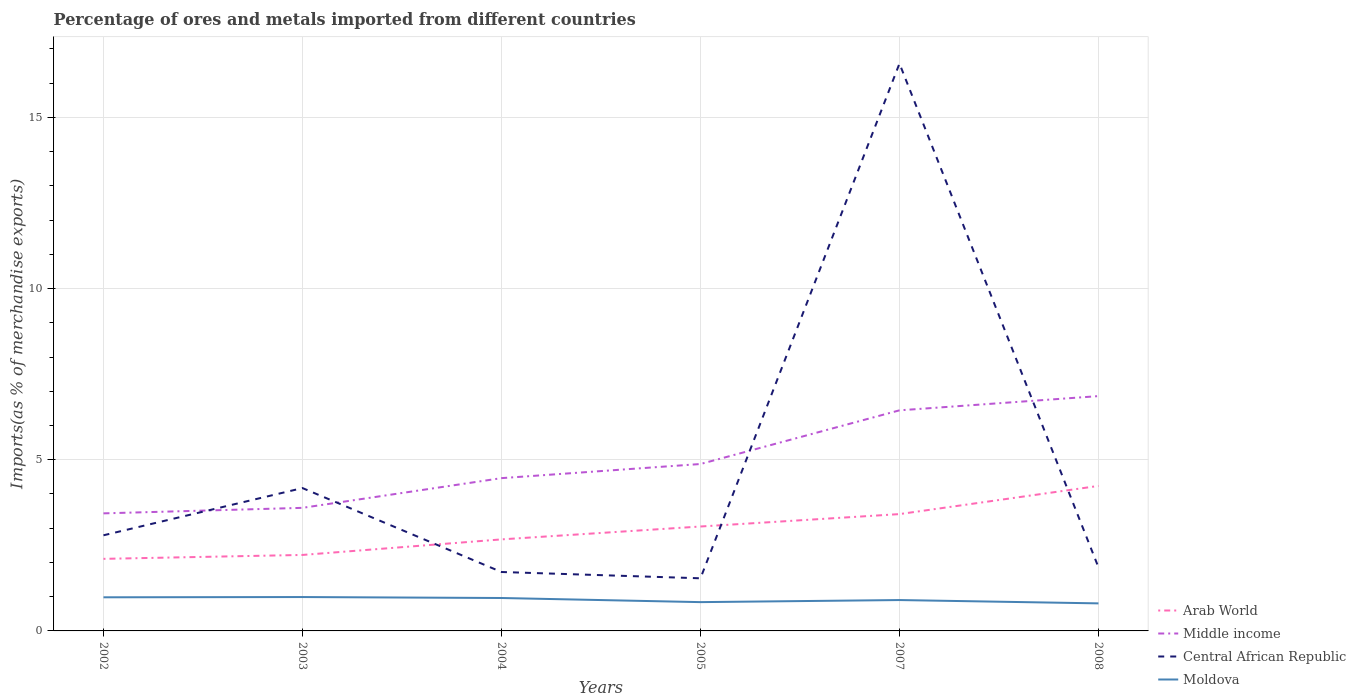Does the line corresponding to Arab World intersect with the line corresponding to Central African Republic?
Your response must be concise. Yes. Across all years, what is the maximum percentage of imports to different countries in Middle income?
Give a very brief answer. 3.43. In which year was the percentage of imports to different countries in Central African Republic maximum?
Offer a terse response. 2005. What is the total percentage of imports to different countries in Moldova in the graph?
Make the answer very short. 0.08. What is the difference between the highest and the second highest percentage of imports to different countries in Arab World?
Keep it short and to the point. 2.13. What is the difference between the highest and the lowest percentage of imports to different countries in Moldova?
Keep it short and to the point. 3. Is the percentage of imports to different countries in Arab World strictly greater than the percentage of imports to different countries in Moldova over the years?
Keep it short and to the point. No. How many years are there in the graph?
Your response must be concise. 6. Are the values on the major ticks of Y-axis written in scientific E-notation?
Your answer should be compact. No. Does the graph contain grids?
Offer a terse response. Yes. Where does the legend appear in the graph?
Your answer should be very brief. Bottom right. How many legend labels are there?
Offer a very short reply. 4. What is the title of the graph?
Provide a succinct answer. Percentage of ores and metals imported from different countries. Does "Belize" appear as one of the legend labels in the graph?
Offer a terse response. No. What is the label or title of the Y-axis?
Ensure brevity in your answer.  Imports(as % of merchandise exports). What is the Imports(as % of merchandise exports) in Arab World in 2002?
Offer a terse response. 2.11. What is the Imports(as % of merchandise exports) in Middle income in 2002?
Offer a terse response. 3.43. What is the Imports(as % of merchandise exports) in Central African Republic in 2002?
Give a very brief answer. 2.79. What is the Imports(as % of merchandise exports) in Moldova in 2002?
Make the answer very short. 0.98. What is the Imports(as % of merchandise exports) of Arab World in 2003?
Your answer should be compact. 2.22. What is the Imports(as % of merchandise exports) in Middle income in 2003?
Your answer should be very brief. 3.6. What is the Imports(as % of merchandise exports) of Central African Republic in 2003?
Ensure brevity in your answer.  4.17. What is the Imports(as % of merchandise exports) of Moldova in 2003?
Your answer should be compact. 0.99. What is the Imports(as % of merchandise exports) of Arab World in 2004?
Offer a terse response. 2.67. What is the Imports(as % of merchandise exports) of Middle income in 2004?
Provide a succinct answer. 4.46. What is the Imports(as % of merchandise exports) in Central African Republic in 2004?
Offer a very short reply. 1.72. What is the Imports(as % of merchandise exports) of Moldova in 2004?
Offer a very short reply. 0.96. What is the Imports(as % of merchandise exports) in Arab World in 2005?
Give a very brief answer. 3.05. What is the Imports(as % of merchandise exports) in Middle income in 2005?
Keep it short and to the point. 4.88. What is the Imports(as % of merchandise exports) of Central African Republic in 2005?
Your response must be concise. 1.54. What is the Imports(as % of merchandise exports) of Moldova in 2005?
Ensure brevity in your answer.  0.84. What is the Imports(as % of merchandise exports) in Arab World in 2007?
Your answer should be very brief. 3.41. What is the Imports(as % of merchandise exports) of Middle income in 2007?
Give a very brief answer. 6.44. What is the Imports(as % of merchandise exports) in Central African Republic in 2007?
Offer a very short reply. 16.57. What is the Imports(as % of merchandise exports) of Moldova in 2007?
Ensure brevity in your answer.  0.9. What is the Imports(as % of merchandise exports) of Arab World in 2008?
Your answer should be compact. 4.24. What is the Imports(as % of merchandise exports) in Middle income in 2008?
Give a very brief answer. 6.86. What is the Imports(as % of merchandise exports) in Central African Republic in 2008?
Keep it short and to the point. 1.86. What is the Imports(as % of merchandise exports) of Moldova in 2008?
Your response must be concise. 0.8. Across all years, what is the maximum Imports(as % of merchandise exports) in Arab World?
Provide a short and direct response. 4.24. Across all years, what is the maximum Imports(as % of merchandise exports) of Middle income?
Keep it short and to the point. 6.86. Across all years, what is the maximum Imports(as % of merchandise exports) in Central African Republic?
Offer a very short reply. 16.57. Across all years, what is the maximum Imports(as % of merchandise exports) of Moldova?
Offer a very short reply. 0.99. Across all years, what is the minimum Imports(as % of merchandise exports) in Arab World?
Your response must be concise. 2.11. Across all years, what is the minimum Imports(as % of merchandise exports) in Middle income?
Offer a very short reply. 3.43. Across all years, what is the minimum Imports(as % of merchandise exports) of Central African Republic?
Your answer should be compact. 1.54. Across all years, what is the minimum Imports(as % of merchandise exports) in Moldova?
Ensure brevity in your answer.  0.8. What is the total Imports(as % of merchandise exports) in Arab World in the graph?
Your answer should be compact. 17.7. What is the total Imports(as % of merchandise exports) of Middle income in the graph?
Your answer should be very brief. 29.67. What is the total Imports(as % of merchandise exports) of Central African Republic in the graph?
Ensure brevity in your answer.  28.66. What is the total Imports(as % of merchandise exports) of Moldova in the graph?
Make the answer very short. 5.48. What is the difference between the Imports(as % of merchandise exports) in Arab World in 2002 and that in 2003?
Offer a terse response. -0.11. What is the difference between the Imports(as % of merchandise exports) of Middle income in 2002 and that in 2003?
Make the answer very short. -0.16. What is the difference between the Imports(as % of merchandise exports) in Central African Republic in 2002 and that in 2003?
Provide a short and direct response. -1.38. What is the difference between the Imports(as % of merchandise exports) of Moldova in 2002 and that in 2003?
Your response must be concise. -0.01. What is the difference between the Imports(as % of merchandise exports) of Arab World in 2002 and that in 2004?
Offer a very short reply. -0.57. What is the difference between the Imports(as % of merchandise exports) of Middle income in 2002 and that in 2004?
Provide a short and direct response. -1.03. What is the difference between the Imports(as % of merchandise exports) in Central African Republic in 2002 and that in 2004?
Your answer should be very brief. 1.07. What is the difference between the Imports(as % of merchandise exports) in Moldova in 2002 and that in 2004?
Offer a very short reply. 0.02. What is the difference between the Imports(as % of merchandise exports) of Arab World in 2002 and that in 2005?
Ensure brevity in your answer.  -0.94. What is the difference between the Imports(as % of merchandise exports) in Middle income in 2002 and that in 2005?
Offer a terse response. -1.44. What is the difference between the Imports(as % of merchandise exports) of Central African Republic in 2002 and that in 2005?
Your answer should be very brief. 1.26. What is the difference between the Imports(as % of merchandise exports) in Moldova in 2002 and that in 2005?
Provide a succinct answer. 0.14. What is the difference between the Imports(as % of merchandise exports) of Arab World in 2002 and that in 2007?
Provide a short and direct response. -1.31. What is the difference between the Imports(as % of merchandise exports) of Middle income in 2002 and that in 2007?
Provide a succinct answer. -3.01. What is the difference between the Imports(as % of merchandise exports) in Central African Republic in 2002 and that in 2007?
Give a very brief answer. -13.78. What is the difference between the Imports(as % of merchandise exports) in Moldova in 2002 and that in 2007?
Your answer should be very brief. 0.08. What is the difference between the Imports(as % of merchandise exports) in Arab World in 2002 and that in 2008?
Offer a terse response. -2.13. What is the difference between the Imports(as % of merchandise exports) of Middle income in 2002 and that in 2008?
Give a very brief answer. -3.43. What is the difference between the Imports(as % of merchandise exports) of Central African Republic in 2002 and that in 2008?
Your answer should be very brief. 0.94. What is the difference between the Imports(as % of merchandise exports) in Moldova in 2002 and that in 2008?
Your response must be concise. 0.18. What is the difference between the Imports(as % of merchandise exports) in Arab World in 2003 and that in 2004?
Your answer should be compact. -0.45. What is the difference between the Imports(as % of merchandise exports) of Middle income in 2003 and that in 2004?
Give a very brief answer. -0.87. What is the difference between the Imports(as % of merchandise exports) of Central African Republic in 2003 and that in 2004?
Ensure brevity in your answer.  2.45. What is the difference between the Imports(as % of merchandise exports) in Moldova in 2003 and that in 2004?
Give a very brief answer. 0.03. What is the difference between the Imports(as % of merchandise exports) in Arab World in 2003 and that in 2005?
Offer a very short reply. -0.83. What is the difference between the Imports(as % of merchandise exports) of Middle income in 2003 and that in 2005?
Provide a succinct answer. -1.28. What is the difference between the Imports(as % of merchandise exports) in Central African Republic in 2003 and that in 2005?
Your answer should be very brief. 2.64. What is the difference between the Imports(as % of merchandise exports) of Moldova in 2003 and that in 2005?
Make the answer very short. 0.15. What is the difference between the Imports(as % of merchandise exports) of Arab World in 2003 and that in 2007?
Offer a very short reply. -1.19. What is the difference between the Imports(as % of merchandise exports) in Middle income in 2003 and that in 2007?
Your answer should be very brief. -2.85. What is the difference between the Imports(as % of merchandise exports) in Central African Republic in 2003 and that in 2007?
Your response must be concise. -12.4. What is the difference between the Imports(as % of merchandise exports) of Moldova in 2003 and that in 2007?
Ensure brevity in your answer.  0.09. What is the difference between the Imports(as % of merchandise exports) in Arab World in 2003 and that in 2008?
Your answer should be compact. -2.02. What is the difference between the Imports(as % of merchandise exports) in Middle income in 2003 and that in 2008?
Keep it short and to the point. -3.26. What is the difference between the Imports(as % of merchandise exports) of Central African Republic in 2003 and that in 2008?
Give a very brief answer. 2.32. What is the difference between the Imports(as % of merchandise exports) in Moldova in 2003 and that in 2008?
Keep it short and to the point. 0.18. What is the difference between the Imports(as % of merchandise exports) of Arab World in 2004 and that in 2005?
Make the answer very short. -0.38. What is the difference between the Imports(as % of merchandise exports) in Middle income in 2004 and that in 2005?
Make the answer very short. -0.41. What is the difference between the Imports(as % of merchandise exports) of Central African Republic in 2004 and that in 2005?
Provide a succinct answer. 0.18. What is the difference between the Imports(as % of merchandise exports) of Moldova in 2004 and that in 2005?
Your answer should be very brief. 0.12. What is the difference between the Imports(as % of merchandise exports) of Arab World in 2004 and that in 2007?
Your answer should be compact. -0.74. What is the difference between the Imports(as % of merchandise exports) in Middle income in 2004 and that in 2007?
Your answer should be very brief. -1.98. What is the difference between the Imports(as % of merchandise exports) of Central African Republic in 2004 and that in 2007?
Ensure brevity in your answer.  -14.85. What is the difference between the Imports(as % of merchandise exports) in Moldova in 2004 and that in 2007?
Provide a short and direct response. 0.06. What is the difference between the Imports(as % of merchandise exports) in Arab World in 2004 and that in 2008?
Provide a succinct answer. -1.56. What is the difference between the Imports(as % of merchandise exports) in Middle income in 2004 and that in 2008?
Offer a terse response. -2.4. What is the difference between the Imports(as % of merchandise exports) in Central African Republic in 2004 and that in 2008?
Ensure brevity in your answer.  -0.14. What is the difference between the Imports(as % of merchandise exports) in Moldova in 2004 and that in 2008?
Make the answer very short. 0.16. What is the difference between the Imports(as % of merchandise exports) of Arab World in 2005 and that in 2007?
Your response must be concise. -0.36. What is the difference between the Imports(as % of merchandise exports) in Middle income in 2005 and that in 2007?
Give a very brief answer. -1.57. What is the difference between the Imports(as % of merchandise exports) of Central African Republic in 2005 and that in 2007?
Your response must be concise. -15.04. What is the difference between the Imports(as % of merchandise exports) in Moldova in 2005 and that in 2007?
Provide a short and direct response. -0.06. What is the difference between the Imports(as % of merchandise exports) of Arab World in 2005 and that in 2008?
Keep it short and to the point. -1.19. What is the difference between the Imports(as % of merchandise exports) of Middle income in 2005 and that in 2008?
Your response must be concise. -1.98. What is the difference between the Imports(as % of merchandise exports) of Central African Republic in 2005 and that in 2008?
Give a very brief answer. -0.32. What is the difference between the Imports(as % of merchandise exports) in Moldova in 2005 and that in 2008?
Make the answer very short. 0.04. What is the difference between the Imports(as % of merchandise exports) in Arab World in 2007 and that in 2008?
Your answer should be compact. -0.82. What is the difference between the Imports(as % of merchandise exports) of Middle income in 2007 and that in 2008?
Offer a very short reply. -0.42. What is the difference between the Imports(as % of merchandise exports) of Central African Republic in 2007 and that in 2008?
Offer a terse response. 14.72. What is the difference between the Imports(as % of merchandise exports) of Moldova in 2007 and that in 2008?
Give a very brief answer. 0.1. What is the difference between the Imports(as % of merchandise exports) of Arab World in 2002 and the Imports(as % of merchandise exports) of Middle income in 2003?
Provide a short and direct response. -1.49. What is the difference between the Imports(as % of merchandise exports) of Arab World in 2002 and the Imports(as % of merchandise exports) of Central African Republic in 2003?
Ensure brevity in your answer.  -2.07. What is the difference between the Imports(as % of merchandise exports) of Arab World in 2002 and the Imports(as % of merchandise exports) of Moldova in 2003?
Your response must be concise. 1.12. What is the difference between the Imports(as % of merchandise exports) in Middle income in 2002 and the Imports(as % of merchandise exports) in Central African Republic in 2003?
Your answer should be compact. -0.74. What is the difference between the Imports(as % of merchandise exports) of Middle income in 2002 and the Imports(as % of merchandise exports) of Moldova in 2003?
Keep it short and to the point. 2.44. What is the difference between the Imports(as % of merchandise exports) of Central African Republic in 2002 and the Imports(as % of merchandise exports) of Moldova in 2003?
Ensure brevity in your answer.  1.8. What is the difference between the Imports(as % of merchandise exports) in Arab World in 2002 and the Imports(as % of merchandise exports) in Middle income in 2004?
Provide a short and direct response. -2.36. What is the difference between the Imports(as % of merchandise exports) of Arab World in 2002 and the Imports(as % of merchandise exports) of Central African Republic in 2004?
Make the answer very short. 0.38. What is the difference between the Imports(as % of merchandise exports) of Arab World in 2002 and the Imports(as % of merchandise exports) of Moldova in 2004?
Make the answer very short. 1.14. What is the difference between the Imports(as % of merchandise exports) of Middle income in 2002 and the Imports(as % of merchandise exports) of Central African Republic in 2004?
Keep it short and to the point. 1.71. What is the difference between the Imports(as % of merchandise exports) of Middle income in 2002 and the Imports(as % of merchandise exports) of Moldova in 2004?
Make the answer very short. 2.47. What is the difference between the Imports(as % of merchandise exports) in Central African Republic in 2002 and the Imports(as % of merchandise exports) in Moldova in 2004?
Provide a short and direct response. 1.83. What is the difference between the Imports(as % of merchandise exports) of Arab World in 2002 and the Imports(as % of merchandise exports) of Middle income in 2005?
Provide a succinct answer. -2.77. What is the difference between the Imports(as % of merchandise exports) in Arab World in 2002 and the Imports(as % of merchandise exports) in Central African Republic in 2005?
Ensure brevity in your answer.  0.57. What is the difference between the Imports(as % of merchandise exports) in Arab World in 2002 and the Imports(as % of merchandise exports) in Moldova in 2005?
Give a very brief answer. 1.26. What is the difference between the Imports(as % of merchandise exports) in Middle income in 2002 and the Imports(as % of merchandise exports) in Central African Republic in 2005?
Your answer should be compact. 1.9. What is the difference between the Imports(as % of merchandise exports) in Middle income in 2002 and the Imports(as % of merchandise exports) in Moldova in 2005?
Your answer should be very brief. 2.59. What is the difference between the Imports(as % of merchandise exports) in Central African Republic in 2002 and the Imports(as % of merchandise exports) in Moldova in 2005?
Ensure brevity in your answer.  1.95. What is the difference between the Imports(as % of merchandise exports) in Arab World in 2002 and the Imports(as % of merchandise exports) in Middle income in 2007?
Your answer should be very brief. -4.34. What is the difference between the Imports(as % of merchandise exports) in Arab World in 2002 and the Imports(as % of merchandise exports) in Central African Republic in 2007?
Offer a terse response. -14.47. What is the difference between the Imports(as % of merchandise exports) of Arab World in 2002 and the Imports(as % of merchandise exports) of Moldova in 2007?
Make the answer very short. 1.2. What is the difference between the Imports(as % of merchandise exports) of Middle income in 2002 and the Imports(as % of merchandise exports) of Central African Republic in 2007?
Offer a terse response. -13.14. What is the difference between the Imports(as % of merchandise exports) in Middle income in 2002 and the Imports(as % of merchandise exports) in Moldova in 2007?
Offer a very short reply. 2.53. What is the difference between the Imports(as % of merchandise exports) in Central African Republic in 2002 and the Imports(as % of merchandise exports) in Moldova in 2007?
Give a very brief answer. 1.89. What is the difference between the Imports(as % of merchandise exports) in Arab World in 2002 and the Imports(as % of merchandise exports) in Middle income in 2008?
Make the answer very short. -4.75. What is the difference between the Imports(as % of merchandise exports) in Arab World in 2002 and the Imports(as % of merchandise exports) in Central African Republic in 2008?
Provide a succinct answer. 0.25. What is the difference between the Imports(as % of merchandise exports) of Arab World in 2002 and the Imports(as % of merchandise exports) of Moldova in 2008?
Give a very brief answer. 1.3. What is the difference between the Imports(as % of merchandise exports) of Middle income in 2002 and the Imports(as % of merchandise exports) of Central African Republic in 2008?
Provide a succinct answer. 1.58. What is the difference between the Imports(as % of merchandise exports) in Middle income in 2002 and the Imports(as % of merchandise exports) in Moldova in 2008?
Your answer should be compact. 2.63. What is the difference between the Imports(as % of merchandise exports) in Central African Republic in 2002 and the Imports(as % of merchandise exports) in Moldova in 2008?
Keep it short and to the point. 1.99. What is the difference between the Imports(as % of merchandise exports) of Arab World in 2003 and the Imports(as % of merchandise exports) of Middle income in 2004?
Give a very brief answer. -2.24. What is the difference between the Imports(as % of merchandise exports) of Arab World in 2003 and the Imports(as % of merchandise exports) of Central African Republic in 2004?
Offer a very short reply. 0.5. What is the difference between the Imports(as % of merchandise exports) in Arab World in 2003 and the Imports(as % of merchandise exports) in Moldova in 2004?
Offer a terse response. 1.26. What is the difference between the Imports(as % of merchandise exports) of Middle income in 2003 and the Imports(as % of merchandise exports) of Central African Republic in 2004?
Offer a very short reply. 1.87. What is the difference between the Imports(as % of merchandise exports) of Middle income in 2003 and the Imports(as % of merchandise exports) of Moldova in 2004?
Provide a succinct answer. 2.63. What is the difference between the Imports(as % of merchandise exports) in Central African Republic in 2003 and the Imports(as % of merchandise exports) in Moldova in 2004?
Your answer should be very brief. 3.21. What is the difference between the Imports(as % of merchandise exports) in Arab World in 2003 and the Imports(as % of merchandise exports) in Middle income in 2005?
Offer a terse response. -2.66. What is the difference between the Imports(as % of merchandise exports) in Arab World in 2003 and the Imports(as % of merchandise exports) in Central African Republic in 2005?
Your answer should be very brief. 0.68. What is the difference between the Imports(as % of merchandise exports) of Arab World in 2003 and the Imports(as % of merchandise exports) of Moldova in 2005?
Give a very brief answer. 1.38. What is the difference between the Imports(as % of merchandise exports) in Middle income in 2003 and the Imports(as % of merchandise exports) in Central African Republic in 2005?
Keep it short and to the point. 2.06. What is the difference between the Imports(as % of merchandise exports) of Middle income in 2003 and the Imports(as % of merchandise exports) of Moldova in 2005?
Ensure brevity in your answer.  2.75. What is the difference between the Imports(as % of merchandise exports) in Central African Republic in 2003 and the Imports(as % of merchandise exports) in Moldova in 2005?
Offer a very short reply. 3.33. What is the difference between the Imports(as % of merchandise exports) of Arab World in 2003 and the Imports(as % of merchandise exports) of Middle income in 2007?
Make the answer very short. -4.22. What is the difference between the Imports(as % of merchandise exports) in Arab World in 2003 and the Imports(as % of merchandise exports) in Central African Republic in 2007?
Give a very brief answer. -14.35. What is the difference between the Imports(as % of merchandise exports) of Arab World in 2003 and the Imports(as % of merchandise exports) of Moldova in 2007?
Your answer should be very brief. 1.32. What is the difference between the Imports(as % of merchandise exports) of Middle income in 2003 and the Imports(as % of merchandise exports) of Central African Republic in 2007?
Provide a succinct answer. -12.98. What is the difference between the Imports(as % of merchandise exports) in Middle income in 2003 and the Imports(as % of merchandise exports) in Moldova in 2007?
Your response must be concise. 2.69. What is the difference between the Imports(as % of merchandise exports) in Central African Republic in 2003 and the Imports(as % of merchandise exports) in Moldova in 2007?
Offer a terse response. 3.27. What is the difference between the Imports(as % of merchandise exports) of Arab World in 2003 and the Imports(as % of merchandise exports) of Middle income in 2008?
Ensure brevity in your answer.  -4.64. What is the difference between the Imports(as % of merchandise exports) of Arab World in 2003 and the Imports(as % of merchandise exports) of Central African Republic in 2008?
Provide a short and direct response. 0.36. What is the difference between the Imports(as % of merchandise exports) in Arab World in 2003 and the Imports(as % of merchandise exports) in Moldova in 2008?
Provide a short and direct response. 1.41. What is the difference between the Imports(as % of merchandise exports) of Middle income in 2003 and the Imports(as % of merchandise exports) of Central African Republic in 2008?
Provide a succinct answer. 1.74. What is the difference between the Imports(as % of merchandise exports) of Middle income in 2003 and the Imports(as % of merchandise exports) of Moldova in 2008?
Your answer should be compact. 2.79. What is the difference between the Imports(as % of merchandise exports) in Central African Republic in 2003 and the Imports(as % of merchandise exports) in Moldova in 2008?
Your response must be concise. 3.37. What is the difference between the Imports(as % of merchandise exports) in Arab World in 2004 and the Imports(as % of merchandise exports) in Middle income in 2005?
Provide a succinct answer. -2.2. What is the difference between the Imports(as % of merchandise exports) in Arab World in 2004 and the Imports(as % of merchandise exports) in Central African Republic in 2005?
Your response must be concise. 1.14. What is the difference between the Imports(as % of merchandise exports) of Arab World in 2004 and the Imports(as % of merchandise exports) of Moldova in 2005?
Offer a very short reply. 1.83. What is the difference between the Imports(as % of merchandise exports) of Middle income in 2004 and the Imports(as % of merchandise exports) of Central African Republic in 2005?
Make the answer very short. 2.93. What is the difference between the Imports(as % of merchandise exports) of Middle income in 2004 and the Imports(as % of merchandise exports) of Moldova in 2005?
Give a very brief answer. 3.62. What is the difference between the Imports(as % of merchandise exports) in Central African Republic in 2004 and the Imports(as % of merchandise exports) in Moldova in 2005?
Provide a short and direct response. 0.88. What is the difference between the Imports(as % of merchandise exports) of Arab World in 2004 and the Imports(as % of merchandise exports) of Middle income in 2007?
Offer a terse response. -3.77. What is the difference between the Imports(as % of merchandise exports) of Arab World in 2004 and the Imports(as % of merchandise exports) of Central African Republic in 2007?
Ensure brevity in your answer.  -13.9. What is the difference between the Imports(as % of merchandise exports) in Arab World in 2004 and the Imports(as % of merchandise exports) in Moldova in 2007?
Your answer should be compact. 1.77. What is the difference between the Imports(as % of merchandise exports) in Middle income in 2004 and the Imports(as % of merchandise exports) in Central African Republic in 2007?
Your answer should be very brief. -12.11. What is the difference between the Imports(as % of merchandise exports) in Middle income in 2004 and the Imports(as % of merchandise exports) in Moldova in 2007?
Your answer should be very brief. 3.56. What is the difference between the Imports(as % of merchandise exports) of Central African Republic in 2004 and the Imports(as % of merchandise exports) of Moldova in 2007?
Your response must be concise. 0.82. What is the difference between the Imports(as % of merchandise exports) in Arab World in 2004 and the Imports(as % of merchandise exports) in Middle income in 2008?
Offer a terse response. -4.19. What is the difference between the Imports(as % of merchandise exports) in Arab World in 2004 and the Imports(as % of merchandise exports) in Central African Republic in 2008?
Ensure brevity in your answer.  0.82. What is the difference between the Imports(as % of merchandise exports) of Arab World in 2004 and the Imports(as % of merchandise exports) of Moldova in 2008?
Keep it short and to the point. 1.87. What is the difference between the Imports(as % of merchandise exports) in Middle income in 2004 and the Imports(as % of merchandise exports) in Central African Republic in 2008?
Your answer should be compact. 2.61. What is the difference between the Imports(as % of merchandise exports) of Middle income in 2004 and the Imports(as % of merchandise exports) of Moldova in 2008?
Your response must be concise. 3.66. What is the difference between the Imports(as % of merchandise exports) of Central African Republic in 2004 and the Imports(as % of merchandise exports) of Moldova in 2008?
Provide a succinct answer. 0.92. What is the difference between the Imports(as % of merchandise exports) of Arab World in 2005 and the Imports(as % of merchandise exports) of Middle income in 2007?
Your response must be concise. -3.39. What is the difference between the Imports(as % of merchandise exports) of Arab World in 2005 and the Imports(as % of merchandise exports) of Central African Republic in 2007?
Ensure brevity in your answer.  -13.52. What is the difference between the Imports(as % of merchandise exports) of Arab World in 2005 and the Imports(as % of merchandise exports) of Moldova in 2007?
Give a very brief answer. 2.15. What is the difference between the Imports(as % of merchandise exports) in Middle income in 2005 and the Imports(as % of merchandise exports) in Central African Republic in 2007?
Your response must be concise. -11.7. What is the difference between the Imports(as % of merchandise exports) of Middle income in 2005 and the Imports(as % of merchandise exports) of Moldova in 2007?
Give a very brief answer. 3.97. What is the difference between the Imports(as % of merchandise exports) in Central African Republic in 2005 and the Imports(as % of merchandise exports) in Moldova in 2007?
Ensure brevity in your answer.  0.64. What is the difference between the Imports(as % of merchandise exports) of Arab World in 2005 and the Imports(as % of merchandise exports) of Middle income in 2008?
Your answer should be compact. -3.81. What is the difference between the Imports(as % of merchandise exports) in Arab World in 2005 and the Imports(as % of merchandise exports) in Central African Republic in 2008?
Your response must be concise. 1.19. What is the difference between the Imports(as % of merchandise exports) in Arab World in 2005 and the Imports(as % of merchandise exports) in Moldova in 2008?
Your response must be concise. 2.25. What is the difference between the Imports(as % of merchandise exports) of Middle income in 2005 and the Imports(as % of merchandise exports) of Central African Republic in 2008?
Provide a short and direct response. 3.02. What is the difference between the Imports(as % of merchandise exports) of Middle income in 2005 and the Imports(as % of merchandise exports) of Moldova in 2008?
Offer a terse response. 4.07. What is the difference between the Imports(as % of merchandise exports) in Central African Republic in 2005 and the Imports(as % of merchandise exports) in Moldova in 2008?
Offer a very short reply. 0.73. What is the difference between the Imports(as % of merchandise exports) of Arab World in 2007 and the Imports(as % of merchandise exports) of Middle income in 2008?
Give a very brief answer. -3.45. What is the difference between the Imports(as % of merchandise exports) of Arab World in 2007 and the Imports(as % of merchandise exports) of Central African Republic in 2008?
Offer a very short reply. 1.56. What is the difference between the Imports(as % of merchandise exports) in Arab World in 2007 and the Imports(as % of merchandise exports) in Moldova in 2008?
Offer a terse response. 2.61. What is the difference between the Imports(as % of merchandise exports) of Middle income in 2007 and the Imports(as % of merchandise exports) of Central African Republic in 2008?
Offer a very short reply. 4.59. What is the difference between the Imports(as % of merchandise exports) in Middle income in 2007 and the Imports(as % of merchandise exports) in Moldova in 2008?
Make the answer very short. 5.64. What is the difference between the Imports(as % of merchandise exports) of Central African Republic in 2007 and the Imports(as % of merchandise exports) of Moldova in 2008?
Your answer should be compact. 15.77. What is the average Imports(as % of merchandise exports) of Arab World per year?
Give a very brief answer. 2.95. What is the average Imports(as % of merchandise exports) of Middle income per year?
Offer a terse response. 4.95. What is the average Imports(as % of merchandise exports) in Central African Republic per year?
Provide a short and direct response. 4.78. What is the average Imports(as % of merchandise exports) in Moldova per year?
Offer a very short reply. 0.91. In the year 2002, what is the difference between the Imports(as % of merchandise exports) of Arab World and Imports(as % of merchandise exports) of Middle income?
Offer a very short reply. -1.33. In the year 2002, what is the difference between the Imports(as % of merchandise exports) in Arab World and Imports(as % of merchandise exports) in Central African Republic?
Offer a very short reply. -0.69. In the year 2002, what is the difference between the Imports(as % of merchandise exports) of Arab World and Imports(as % of merchandise exports) of Moldova?
Ensure brevity in your answer.  1.12. In the year 2002, what is the difference between the Imports(as % of merchandise exports) in Middle income and Imports(as % of merchandise exports) in Central African Republic?
Offer a terse response. 0.64. In the year 2002, what is the difference between the Imports(as % of merchandise exports) in Middle income and Imports(as % of merchandise exports) in Moldova?
Give a very brief answer. 2.45. In the year 2002, what is the difference between the Imports(as % of merchandise exports) of Central African Republic and Imports(as % of merchandise exports) of Moldova?
Offer a terse response. 1.81. In the year 2003, what is the difference between the Imports(as % of merchandise exports) of Arab World and Imports(as % of merchandise exports) of Middle income?
Your answer should be compact. -1.38. In the year 2003, what is the difference between the Imports(as % of merchandise exports) of Arab World and Imports(as % of merchandise exports) of Central African Republic?
Your answer should be very brief. -1.95. In the year 2003, what is the difference between the Imports(as % of merchandise exports) of Arab World and Imports(as % of merchandise exports) of Moldova?
Provide a short and direct response. 1.23. In the year 2003, what is the difference between the Imports(as % of merchandise exports) of Middle income and Imports(as % of merchandise exports) of Central African Republic?
Offer a terse response. -0.58. In the year 2003, what is the difference between the Imports(as % of merchandise exports) in Middle income and Imports(as % of merchandise exports) in Moldova?
Give a very brief answer. 2.61. In the year 2003, what is the difference between the Imports(as % of merchandise exports) of Central African Republic and Imports(as % of merchandise exports) of Moldova?
Make the answer very short. 3.18. In the year 2004, what is the difference between the Imports(as % of merchandise exports) in Arab World and Imports(as % of merchandise exports) in Middle income?
Make the answer very short. -1.79. In the year 2004, what is the difference between the Imports(as % of merchandise exports) in Arab World and Imports(as % of merchandise exports) in Central African Republic?
Give a very brief answer. 0.95. In the year 2004, what is the difference between the Imports(as % of merchandise exports) of Arab World and Imports(as % of merchandise exports) of Moldova?
Provide a succinct answer. 1.71. In the year 2004, what is the difference between the Imports(as % of merchandise exports) of Middle income and Imports(as % of merchandise exports) of Central African Republic?
Provide a short and direct response. 2.74. In the year 2004, what is the difference between the Imports(as % of merchandise exports) of Middle income and Imports(as % of merchandise exports) of Moldova?
Ensure brevity in your answer.  3.5. In the year 2004, what is the difference between the Imports(as % of merchandise exports) in Central African Republic and Imports(as % of merchandise exports) in Moldova?
Provide a succinct answer. 0.76. In the year 2005, what is the difference between the Imports(as % of merchandise exports) of Arab World and Imports(as % of merchandise exports) of Middle income?
Offer a terse response. -1.83. In the year 2005, what is the difference between the Imports(as % of merchandise exports) of Arab World and Imports(as % of merchandise exports) of Central African Republic?
Give a very brief answer. 1.51. In the year 2005, what is the difference between the Imports(as % of merchandise exports) of Arab World and Imports(as % of merchandise exports) of Moldova?
Keep it short and to the point. 2.21. In the year 2005, what is the difference between the Imports(as % of merchandise exports) of Middle income and Imports(as % of merchandise exports) of Central African Republic?
Your response must be concise. 3.34. In the year 2005, what is the difference between the Imports(as % of merchandise exports) of Middle income and Imports(as % of merchandise exports) of Moldova?
Ensure brevity in your answer.  4.03. In the year 2005, what is the difference between the Imports(as % of merchandise exports) of Central African Republic and Imports(as % of merchandise exports) of Moldova?
Ensure brevity in your answer.  0.7. In the year 2007, what is the difference between the Imports(as % of merchandise exports) of Arab World and Imports(as % of merchandise exports) of Middle income?
Ensure brevity in your answer.  -3.03. In the year 2007, what is the difference between the Imports(as % of merchandise exports) of Arab World and Imports(as % of merchandise exports) of Central African Republic?
Ensure brevity in your answer.  -13.16. In the year 2007, what is the difference between the Imports(as % of merchandise exports) of Arab World and Imports(as % of merchandise exports) of Moldova?
Keep it short and to the point. 2.51. In the year 2007, what is the difference between the Imports(as % of merchandise exports) of Middle income and Imports(as % of merchandise exports) of Central African Republic?
Offer a very short reply. -10.13. In the year 2007, what is the difference between the Imports(as % of merchandise exports) of Middle income and Imports(as % of merchandise exports) of Moldova?
Provide a short and direct response. 5.54. In the year 2007, what is the difference between the Imports(as % of merchandise exports) in Central African Republic and Imports(as % of merchandise exports) in Moldova?
Keep it short and to the point. 15.67. In the year 2008, what is the difference between the Imports(as % of merchandise exports) of Arab World and Imports(as % of merchandise exports) of Middle income?
Your response must be concise. -2.62. In the year 2008, what is the difference between the Imports(as % of merchandise exports) of Arab World and Imports(as % of merchandise exports) of Central African Republic?
Offer a terse response. 2.38. In the year 2008, what is the difference between the Imports(as % of merchandise exports) in Arab World and Imports(as % of merchandise exports) in Moldova?
Give a very brief answer. 3.43. In the year 2008, what is the difference between the Imports(as % of merchandise exports) of Middle income and Imports(as % of merchandise exports) of Central African Republic?
Give a very brief answer. 5. In the year 2008, what is the difference between the Imports(as % of merchandise exports) in Middle income and Imports(as % of merchandise exports) in Moldova?
Ensure brevity in your answer.  6.05. In the year 2008, what is the difference between the Imports(as % of merchandise exports) of Central African Republic and Imports(as % of merchandise exports) of Moldova?
Ensure brevity in your answer.  1.05. What is the ratio of the Imports(as % of merchandise exports) in Arab World in 2002 to that in 2003?
Provide a succinct answer. 0.95. What is the ratio of the Imports(as % of merchandise exports) of Middle income in 2002 to that in 2003?
Your response must be concise. 0.96. What is the ratio of the Imports(as % of merchandise exports) of Central African Republic in 2002 to that in 2003?
Your answer should be very brief. 0.67. What is the ratio of the Imports(as % of merchandise exports) in Moldova in 2002 to that in 2003?
Provide a succinct answer. 0.99. What is the ratio of the Imports(as % of merchandise exports) in Arab World in 2002 to that in 2004?
Ensure brevity in your answer.  0.79. What is the ratio of the Imports(as % of merchandise exports) in Middle income in 2002 to that in 2004?
Offer a terse response. 0.77. What is the ratio of the Imports(as % of merchandise exports) of Central African Republic in 2002 to that in 2004?
Offer a very short reply. 1.62. What is the ratio of the Imports(as % of merchandise exports) in Moldova in 2002 to that in 2004?
Give a very brief answer. 1.02. What is the ratio of the Imports(as % of merchandise exports) in Arab World in 2002 to that in 2005?
Provide a succinct answer. 0.69. What is the ratio of the Imports(as % of merchandise exports) in Middle income in 2002 to that in 2005?
Make the answer very short. 0.7. What is the ratio of the Imports(as % of merchandise exports) of Central African Republic in 2002 to that in 2005?
Your answer should be very brief. 1.82. What is the ratio of the Imports(as % of merchandise exports) in Moldova in 2002 to that in 2005?
Make the answer very short. 1.17. What is the ratio of the Imports(as % of merchandise exports) in Arab World in 2002 to that in 2007?
Offer a very short reply. 0.62. What is the ratio of the Imports(as % of merchandise exports) of Middle income in 2002 to that in 2007?
Give a very brief answer. 0.53. What is the ratio of the Imports(as % of merchandise exports) of Central African Republic in 2002 to that in 2007?
Your answer should be compact. 0.17. What is the ratio of the Imports(as % of merchandise exports) of Moldova in 2002 to that in 2007?
Offer a terse response. 1.09. What is the ratio of the Imports(as % of merchandise exports) of Arab World in 2002 to that in 2008?
Keep it short and to the point. 0.5. What is the ratio of the Imports(as % of merchandise exports) of Middle income in 2002 to that in 2008?
Your answer should be very brief. 0.5. What is the ratio of the Imports(as % of merchandise exports) in Central African Republic in 2002 to that in 2008?
Provide a succinct answer. 1.5. What is the ratio of the Imports(as % of merchandise exports) of Moldova in 2002 to that in 2008?
Offer a very short reply. 1.22. What is the ratio of the Imports(as % of merchandise exports) of Arab World in 2003 to that in 2004?
Keep it short and to the point. 0.83. What is the ratio of the Imports(as % of merchandise exports) of Middle income in 2003 to that in 2004?
Your answer should be compact. 0.81. What is the ratio of the Imports(as % of merchandise exports) of Central African Republic in 2003 to that in 2004?
Make the answer very short. 2.42. What is the ratio of the Imports(as % of merchandise exports) in Moldova in 2003 to that in 2004?
Give a very brief answer. 1.03. What is the ratio of the Imports(as % of merchandise exports) of Arab World in 2003 to that in 2005?
Provide a short and direct response. 0.73. What is the ratio of the Imports(as % of merchandise exports) of Middle income in 2003 to that in 2005?
Ensure brevity in your answer.  0.74. What is the ratio of the Imports(as % of merchandise exports) in Central African Republic in 2003 to that in 2005?
Offer a terse response. 2.71. What is the ratio of the Imports(as % of merchandise exports) in Moldova in 2003 to that in 2005?
Ensure brevity in your answer.  1.18. What is the ratio of the Imports(as % of merchandise exports) of Arab World in 2003 to that in 2007?
Give a very brief answer. 0.65. What is the ratio of the Imports(as % of merchandise exports) in Middle income in 2003 to that in 2007?
Make the answer very short. 0.56. What is the ratio of the Imports(as % of merchandise exports) in Central African Republic in 2003 to that in 2007?
Offer a very short reply. 0.25. What is the ratio of the Imports(as % of merchandise exports) of Moldova in 2003 to that in 2007?
Make the answer very short. 1.1. What is the ratio of the Imports(as % of merchandise exports) in Arab World in 2003 to that in 2008?
Keep it short and to the point. 0.52. What is the ratio of the Imports(as % of merchandise exports) in Middle income in 2003 to that in 2008?
Give a very brief answer. 0.52. What is the ratio of the Imports(as % of merchandise exports) in Central African Republic in 2003 to that in 2008?
Offer a terse response. 2.25. What is the ratio of the Imports(as % of merchandise exports) in Moldova in 2003 to that in 2008?
Provide a short and direct response. 1.23. What is the ratio of the Imports(as % of merchandise exports) of Arab World in 2004 to that in 2005?
Provide a succinct answer. 0.88. What is the ratio of the Imports(as % of merchandise exports) in Middle income in 2004 to that in 2005?
Give a very brief answer. 0.92. What is the ratio of the Imports(as % of merchandise exports) of Central African Republic in 2004 to that in 2005?
Keep it short and to the point. 1.12. What is the ratio of the Imports(as % of merchandise exports) of Moldova in 2004 to that in 2005?
Offer a very short reply. 1.14. What is the ratio of the Imports(as % of merchandise exports) in Arab World in 2004 to that in 2007?
Provide a short and direct response. 0.78. What is the ratio of the Imports(as % of merchandise exports) of Middle income in 2004 to that in 2007?
Your response must be concise. 0.69. What is the ratio of the Imports(as % of merchandise exports) in Central African Republic in 2004 to that in 2007?
Your response must be concise. 0.1. What is the ratio of the Imports(as % of merchandise exports) of Moldova in 2004 to that in 2007?
Offer a terse response. 1.07. What is the ratio of the Imports(as % of merchandise exports) of Arab World in 2004 to that in 2008?
Offer a very short reply. 0.63. What is the ratio of the Imports(as % of merchandise exports) of Middle income in 2004 to that in 2008?
Offer a very short reply. 0.65. What is the ratio of the Imports(as % of merchandise exports) of Central African Republic in 2004 to that in 2008?
Offer a very short reply. 0.93. What is the ratio of the Imports(as % of merchandise exports) of Moldova in 2004 to that in 2008?
Your answer should be compact. 1.2. What is the ratio of the Imports(as % of merchandise exports) of Arab World in 2005 to that in 2007?
Provide a succinct answer. 0.89. What is the ratio of the Imports(as % of merchandise exports) of Middle income in 2005 to that in 2007?
Offer a terse response. 0.76. What is the ratio of the Imports(as % of merchandise exports) of Central African Republic in 2005 to that in 2007?
Ensure brevity in your answer.  0.09. What is the ratio of the Imports(as % of merchandise exports) of Moldova in 2005 to that in 2007?
Your answer should be compact. 0.93. What is the ratio of the Imports(as % of merchandise exports) of Arab World in 2005 to that in 2008?
Your answer should be very brief. 0.72. What is the ratio of the Imports(as % of merchandise exports) of Middle income in 2005 to that in 2008?
Give a very brief answer. 0.71. What is the ratio of the Imports(as % of merchandise exports) of Central African Republic in 2005 to that in 2008?
Offer a very short reply. 0.83. What is the ratio of the Imports(as % of merchandise exports) in Moldova in 2005 to that in 2008?
Provide a succinct answer. 1.05. What is the ratio of the Imports(as % of merchandise exports) of Arab World in 2007 to that in 2008?
Keep it short and to the point. 0.81. What is the ratio of the Imports(as % of merchandise exports) of Middle income in 2007 to that in 2008?
Give a very brief answer. 0.94. What is the ratio of the Imports(as % of merchandise exports) of Central African Republic in 2007 to that in 2008?
Provide a succinct answer. 8.92. What is the ratio of the Imports(as % of merchandise exports) of Moldova in 2007 to that in 2008?
Your answer should be compact. 1.12. What is the difference between the highest and the second highest Imports(as % of merchandise exports) of Arab World?
Give a very brief answer. 0.82. What is the difference between the highest and the second highest Imports(as % of merchandise exports) of Middle income?
Offer a terse response. 0.42. What is the difference between the highest and the second highest Imports(as % of merchandise exports) of Central African Republic?
Your answer should be compact. 12.4. What is the difference between the highest and the second highest Imports(as % of merchandise exports) in Moldova?
Keep it short and to the point. 0.01. What is the difference between the highest and the lowest Imports(as % of merchandise exports) of Arab World?
Make the answer very short. 2.13. What is the difference between the highest and the lowest Imports(as % of merchandise exports) of Middle income?
Give a very brief answer. 3.43. What is the difference between the highest and the lowest Imports(as % of merchandise exports) in Central African Republic?
Ensure brevity in your answer.  15.04. What is the difference between the highest and the lowest Imports(as % of merchandise exports) in Moldova?
Provide a short and direct response. 0.18. 